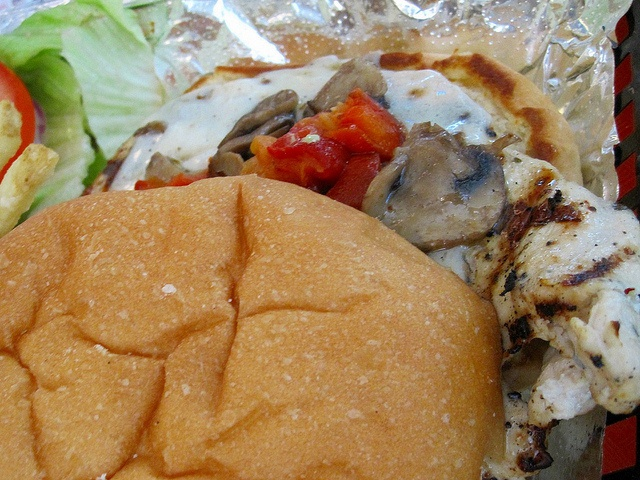Describe the objects in this image and their specific colors. I can see a sandwich in lavender, tan, olive, and gray tones in this image. 